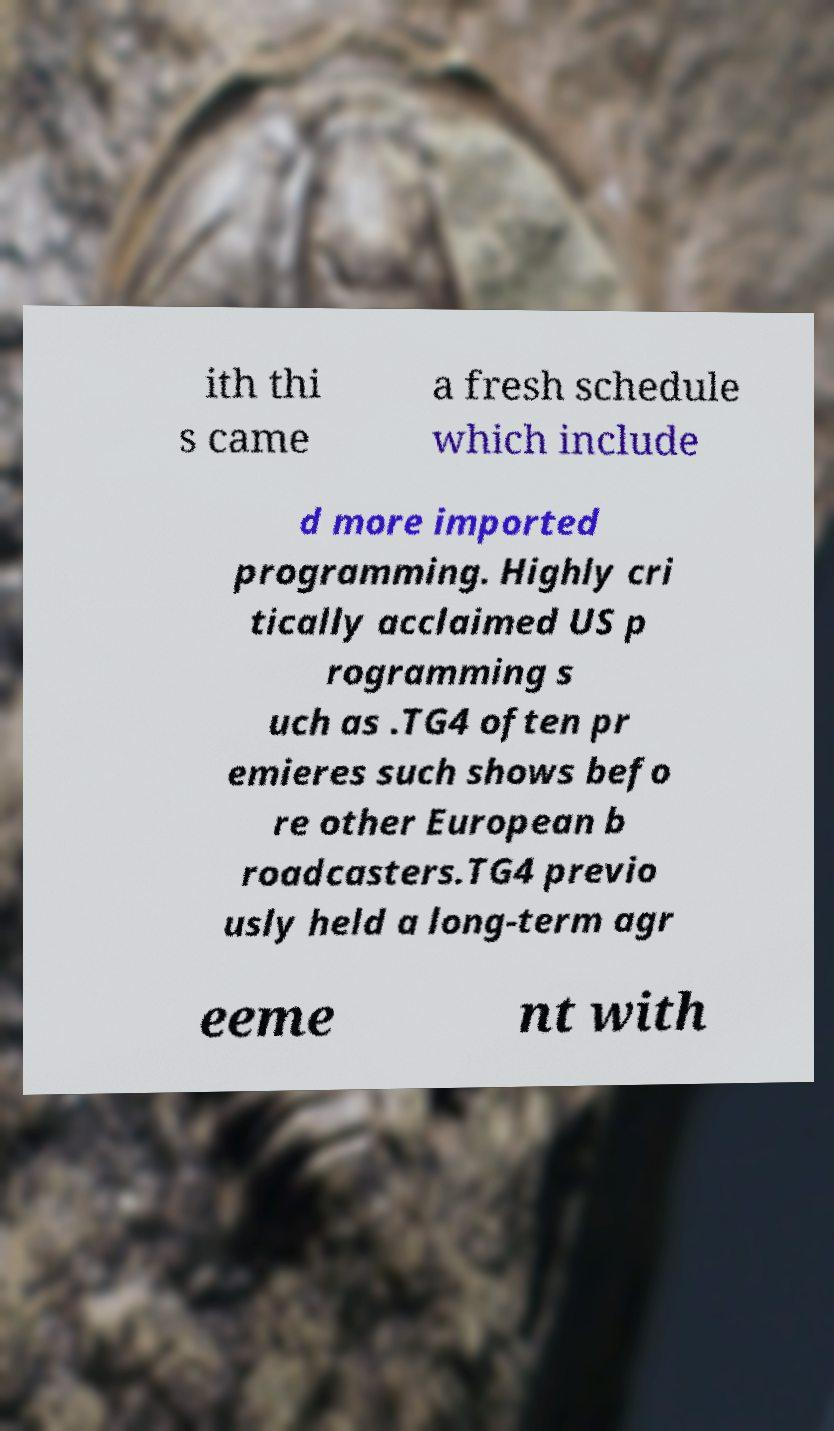What messages or text are displayed in this image? I need them in a readable, typed format. ith thi s came a fresh schedule which include d more imported programming. Highly cri tically acclaimed US p rogramming s uch as .TG4 often pr emieres such shows befo re other European b roadcasters.TG4 previo usly held a long-term agr eeme nt with 